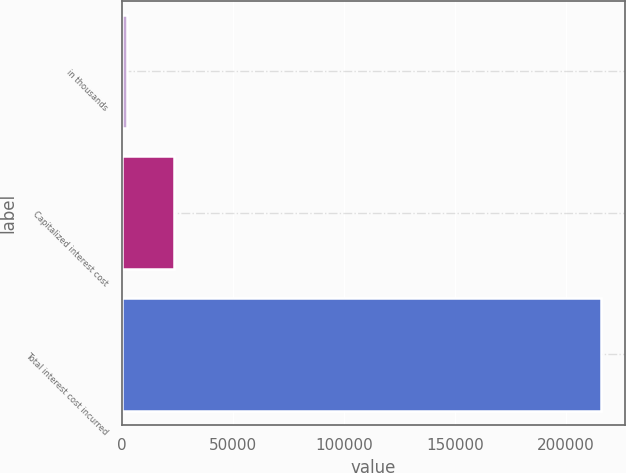Convert chart to OTSL. <chart><loc_0><loc_0><loc_500><loc_500><bar_chart><fcel>in thousands<fcel>Capitalized interest cost<fcel>Total interest cost incurred<nl><fcel>2012<fcel>23389.1<fcel>215783<nl></chart> 